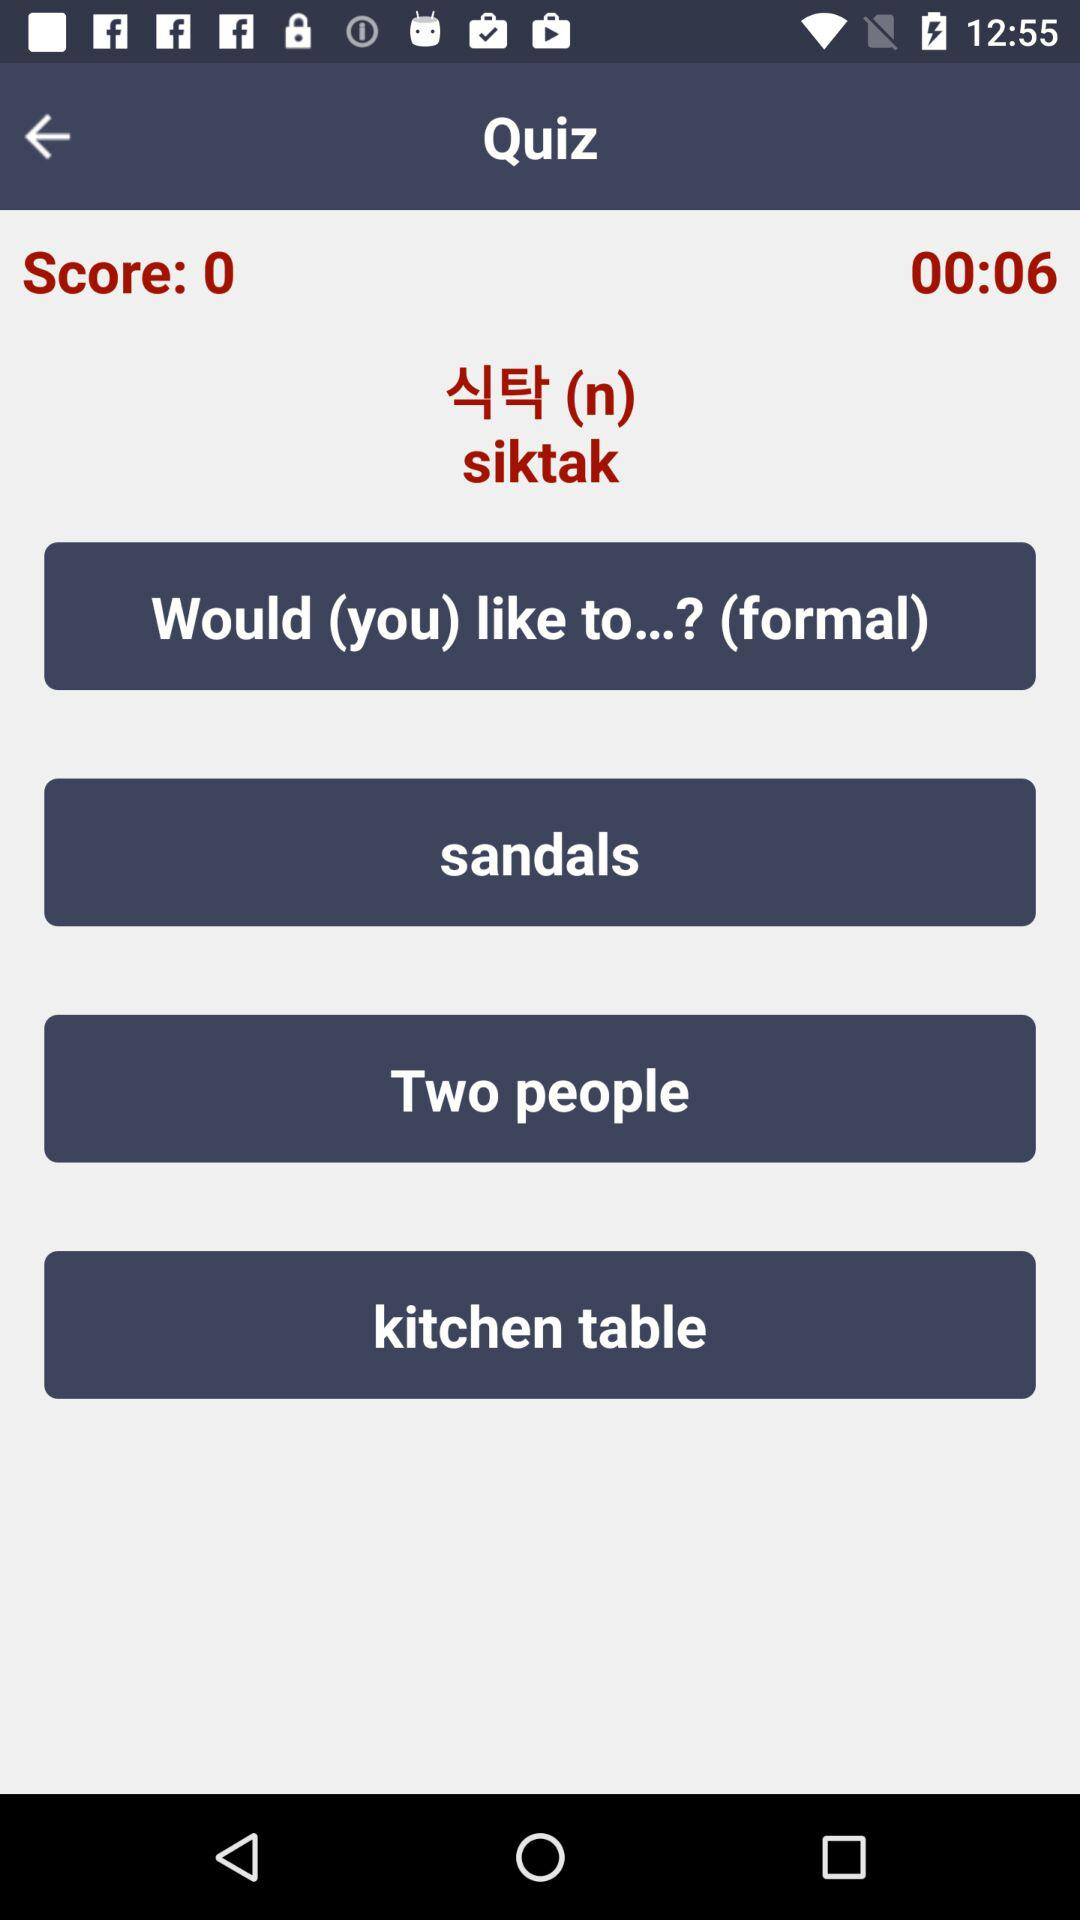How many seconds is left on the timer?
Answer the question using a single word or phrase. 6 